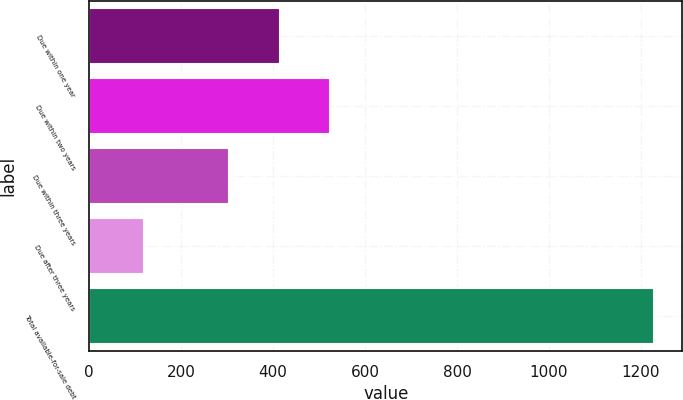Convert chart. <chart><loc_0><loc_0><loc_500><loc_500><bar_chart><fcel>Due within one year<fcel>Due within two years<fcel>Due within three years<fcel>Due after three years<fcel>Total available-for-sale debt<nl><fcel>413.9<fcel>524.8<fcel>303<fcel>120<fcel>1229<nl></chart> 